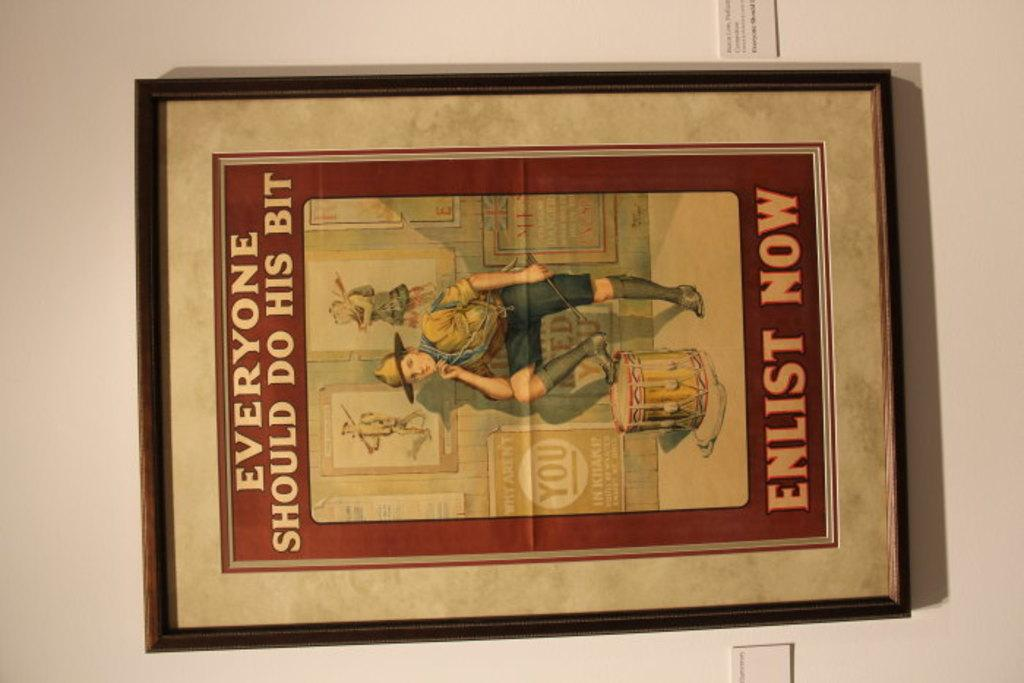<image>
Relay a brief, clear account of the picture shown. A picture of a young man is surrounded by the words Everyone Should Do His Bit Enlist Now 